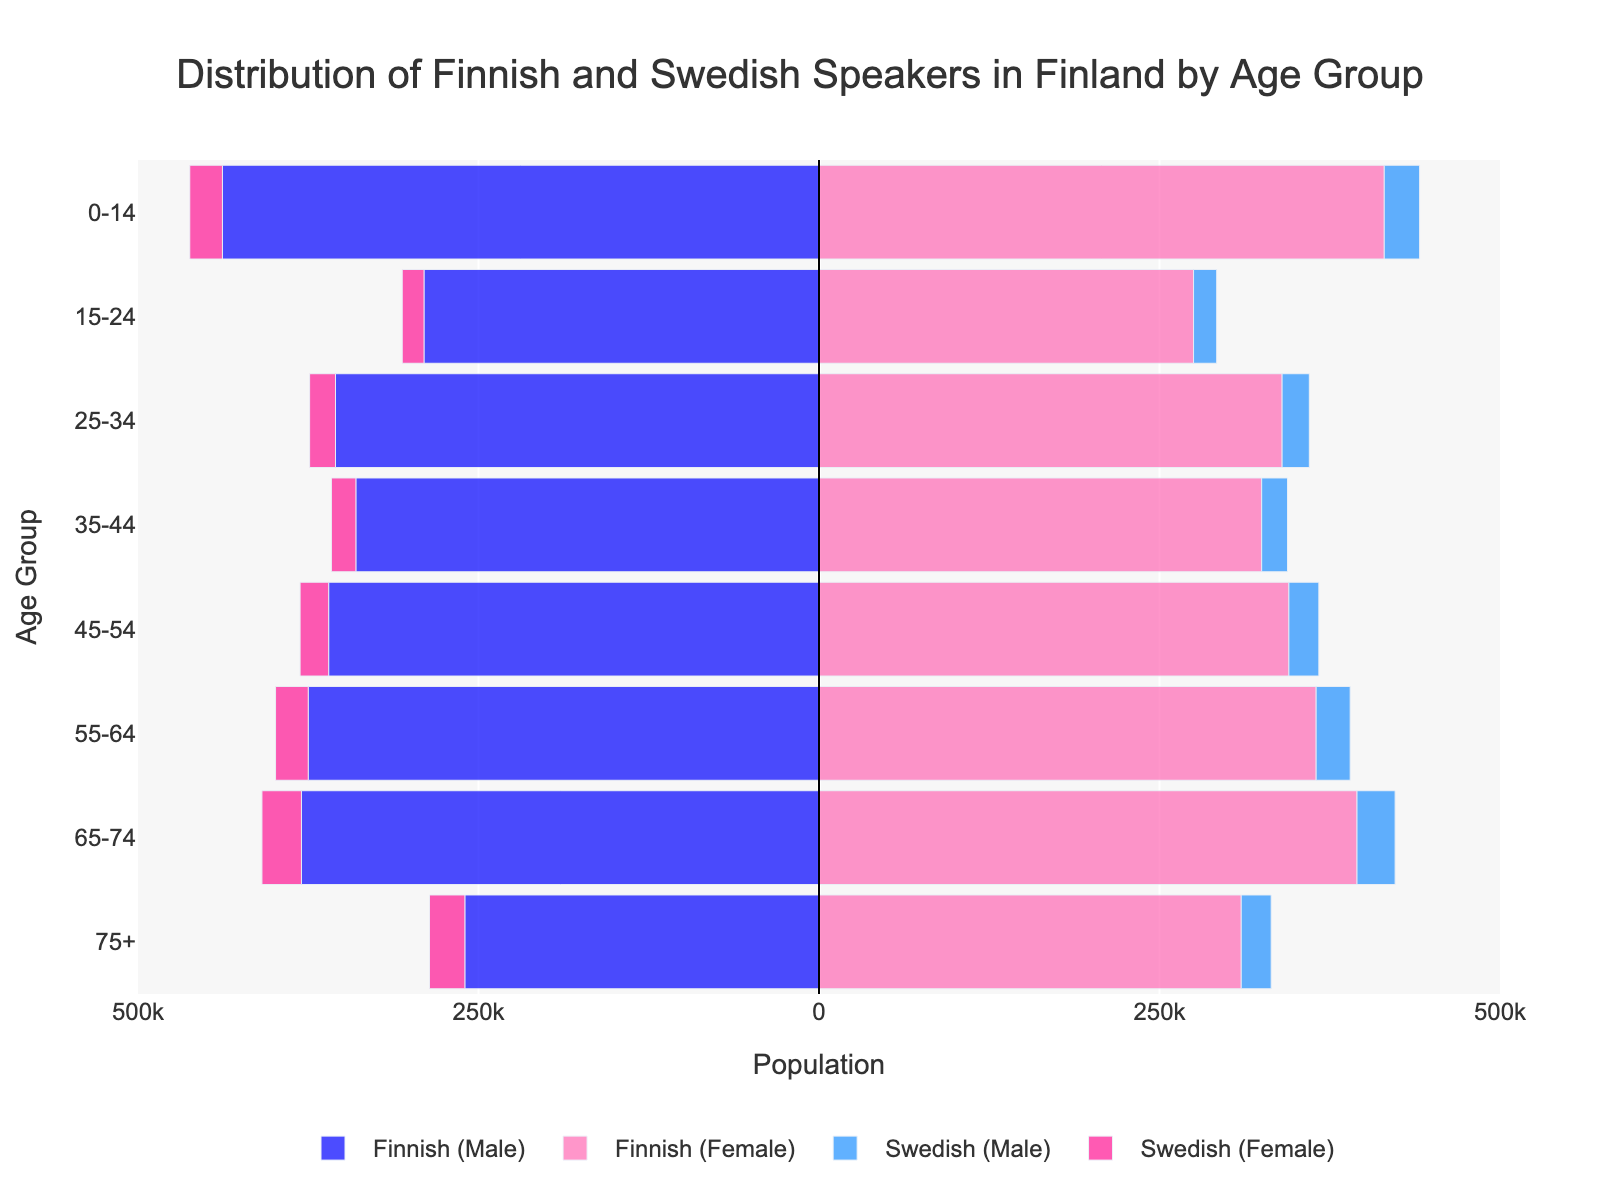What is the title of the figure? The title is usually displayed prominently at the top of the figure. In this case, the title should be read directly from there.
Answer: Distribution of Finnish and Swedish Speakers in Finland by Age Group How many age groups are displayed in the figure? Count the unique age groups listed on the y-axis.
Answer: 8 Which age group has the highest number of native Finnish speakers (both male and female together)? Sum the Finnish speakers (both male and female) for each age group and find the group with the highest sum.
- 0-14: 438000 + 415000 = 853000
- 15-24: 290000 + 275000 = 565000
- 25-34: 355000 + 340000 = 695000
- 35-44: 340000 + 325000 = 665000
- 45-54: 360000 + 345000 = 705000
- 55-64: 375000 + 365000 = 740000
- 65-74: 380000 + 395000 = 775000
- 75+: 260000 + 310000 = 570000
Hence, the age group with the highest number of native Finnish speakers is 0-14.
Answer: 0-14 Which age group has more native Swedish male speakers compared to native Finnish female speakers? Compare the Swedish male speaker count with the Finnish female speaker count for each age group:
- 0-14: 26000 < 415000 (No)
- 15-24: 17000 < 275000 (No)
- 25-34: 20000 < 340000 (No)
- 35-44: 19000 < 325000 (No)
- 45-54: 22000 < 345000 (No)
- 55-64: 25000 < 365000 (No)
- 65-74: 28000 < 395000 (No)
- 75+: 22000 < 310000 (No)
Thus, none of the age groups have more native Swedish male speakers compared to Finnish female speakers.
Answer: None What is the total number of Swedish female speakers in the age group 55-64? Read the negative value for Swedish female speakers in the age group 55-64.
Answer: 24000 How does the population of native Finnish speakers in the age group 45-54 compare to the age group 55-64? Calculate the total population (male + female) of Finnish speakers for both age groups and compare:
- 45-54: 360000 + 345000 = 705000
- 55-64: 375000 + 365000 = 740000
Thus, the 55-64 age group has 740000 - 705000 = 35000 more Finnish speakers compared to the 45-54 age group.
Answer: The 55-64 age group has 35000 more Finnish speakers Which age group has the least number of native Finnish speakers (both male and female together)? Sum the Finnish speakers for each age group and find the group with the lowest sum:
- 0-14: 853000
- 15-24: 565000
- 25-34: 695000
- 35-44: 665000
- 45-54: 705000
- 55-64: 740000
- 65-74: 775000
- 75+: 570000
The least number of Finnish speakers is in the age group 15-24.
Answer: 15-24 Are there more native Swedish female speakers or native Swedish male speakers in the age group 65-74? Compare the counts of Swedish female speakers and Swedish male speakers in the age group 65-74:
- Swedish male: 28000
- Swedish female: 29000
Swedish female speakers are greater in number.
Answer: Swedish female speakers 